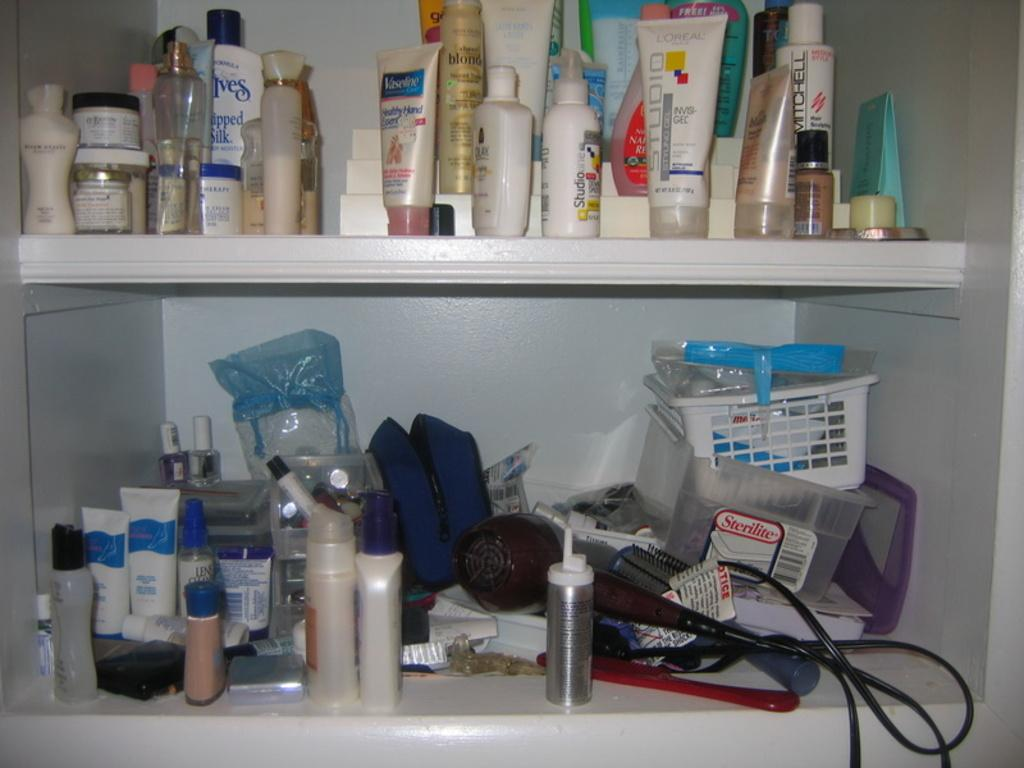<image>
Describe the image concisely. Two shelves of various beauty products including one Vaseline lotion. 